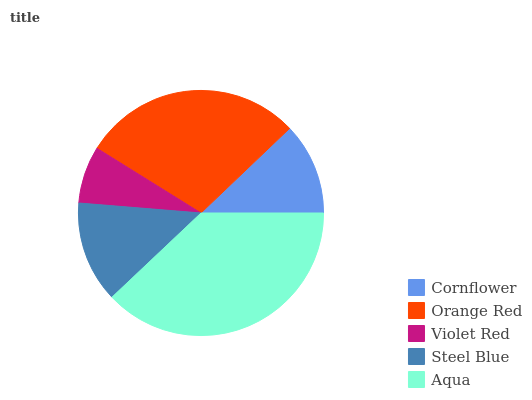Is Violet Red the minimum?
Answer yes or no. Yes. Is Aqua the maximum?
Answer yes or no. Yes. Is Orange Red the minimum?
Answer yes or no. No. Is Orange Red the maximum?
Answer yes or no. No. Is Orange Red greater than Cornflower?
Answer yes or no. Yes. Is Cornflower less than Orange Red?
Answer yes or no. Yes. Is Cornflower greater than Orange Red?
Answer yes or no. No. Is Orange Red less than Cornflower?
Answer yes or no. No. Is Steel Blue the high median?
Answer yes or no. Yes. Is Steel Blue the low median?
Answer yes or no. Yes. Is Orange Red the high median?
Answer yes or no. No. Is Aqua the low median?
Answer yes or no. No. 